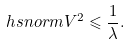<formula> <loc_0><loc_0><loc_500><loc_500>\ h s n o r m { V } ^ { 2 } \leqslant \frac { 1 } { \lambda } .</formula> 